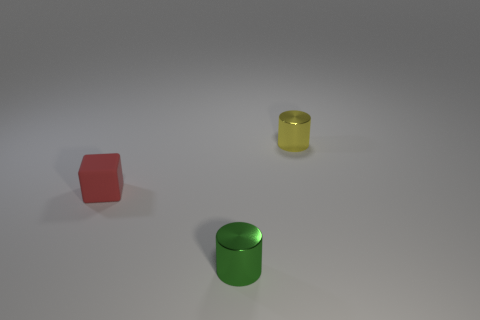Which object stands out the most and why? The green shiny cylinder stands out the most. Its vibrant color and reflective surface draw the eye compared to the matte red cube and the smaller yellow cylinder. Its position in the center of the composition also makes it a focal point. How does the lighting affect the appearance of the objects? The lighting in the image seems to be coming from above, casting soft shadows directly underneath the objects. This highlights the three-dimensionality of the shapes and brings out the reflective quality of the green cylinder, enhancing its visibility. 